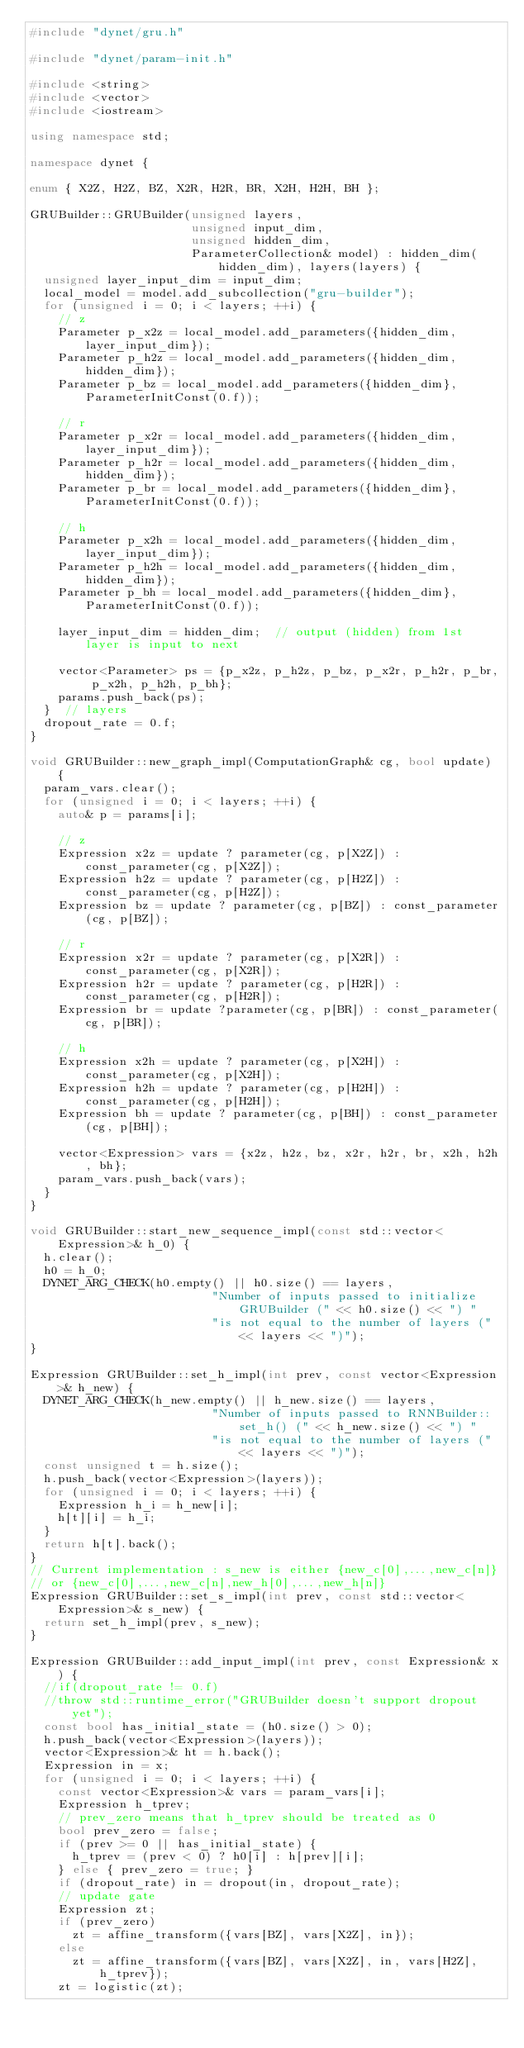<code> <loc_0><loc_0><loc_500><loc_500><_C++_>#include "dynet/gru.h"

#include "dynet/param-init.h"

#include <string>
#include <vector>
#include <iostream>

using namespace std;

namespace dynet {

enum { X2Z, H2Z, BZ, X2R, H2R, BR, X2H, H2H, BH };

GRUBuilder::GRUBuilder(unsigned layers,
                       unsigned input_dim,
                       unsigned hidden_dim,
                       ParameterCollection& model) : hidden_dim(hidden_dim), layers(layers) {
  unsigned layer_input_dim = input_dim;
  local_model = model.add_subcollection("gru-builder");
  for (unsigned i = 0; i < layers; ++i) {
    // z
    Parameter p_x2z = local_model.add_parameters({hidden_dim, layer_input_dim});
    Parameter p_h2z = local_model.add_parameters({hidden_dim, hidden_dim});
    Parameter p_bz = local_model.add_parameters({hidden_dim}, ParameterInitConst(0.f));

    // r
    Parameter p_x2r = local_model.add_parameters({hidden_dim, layer_input_dim});
    Parameter p_h2r = local_model.add_parameters({hidden_dim, hidden_dim});
    Parameter p_br = local_model.add_parameters({hidden_dim}, ParameterInitConst(0.f));

    // h
    Parameter p_x2h = local_model.add_parameters({hidden_dim, layer_input_dim});
    Parameter p_h2h = local_model.add_parameters({hidden_dim, hidden_dim});
    Parameter p_bh = local_model.add_parameters({hidden_dim}, ParameterInitConst(0.f));

    layer_input_dim = hidden_dim;  // output (hidden) from 1st layer is input to next

    vector<Parameter> ps = {p_x2z, p_h2z, p_bz, p_x2r, p_h2r, p_br, p_x2h, p_h2h, p_bh};
    params.push_back(ps);
  }  // layers
  dropout_rate = 0.f;
}

void GRUBuilder::new_graph_impl(ComputationGraph& cg, bool update) {
  param_vars.clear();
  for (unsigned i = 0; i < layers; ++i) {
    auto& p = params[i];

    // z
    Expression x2z = update ? parameter(cg, p[X2Z]) : const_parameter(cg, p[X2Z]);
    Expression h2z = update ? parameter(cg, p[H2Z]) : const_parameter(cg, p[H2Z]);
    Expression bz = update ? parameter(cg, p[BZ]) : const_parameter(cg, p[BZ]);

    // r
    Expression x2r = update ? parameter(cg, p[X2R]) : const_parameter(cg, p[X2R]);
    Expression h2r = update ? parameter(cg, p[H2R]) : const_parameter(cg, p[H2R]);
    Expression br = update ?parameter(cg, p[BR]) : const_parameter(cg, p[BR]);

    // h
    Expression x2h = update ? parameter(cg, p[X2H]) : const_parameter(cg, p[X2H]);
    Expression h2h = update ? parameter(cg, p[H2H]) : const_parameter(cg, p[H2H]);
    Expression bh = update ? parameter(cg, p[BH]) : const_parameter(cg, p[BH]);

    vector<Expression> vars = {x2z, h2z, bz, x2r, h2r, br, x2h, h2h, bh};
    param_vars.push_back(vars);
  }
}

void GRUBuilder::start_new_sequence_impl(const std::vector<Expression>& h_0) {
  h.clear();
  h0 = h_0;
  DYNET_ARG_CHECK(h0.empty() || h0.size() == layers,
                          "Number of inputs passed to initialize GRUBuilder (" << h0.size() << ") "
                          "is not equal to the number of layers (" << layers << ")");
}

Expression GRUBuilder::set_h_impl(int prev, const vector<Expression>& h_new) {
  DYNET_ARG_CHECK(h_new.empty() || h_new.size() == layers,
                          "Number of inputs passed to RNNBuilder::set_h() (" << h_new.size() << ") "
                          "is not equal to the number of layers (" << layers << ")");
  const unsigned t = h.size();
  h.push_back(vector<Expression>(layers));
  for (unsigned i = 0; i < layers; ++i) {
    Expression h_i = h_new[i];
    h[t][i] = h_i;
  }
  return h[t].back();
}
// Current implementation : s_new is either {new_c[0],...,new_c[n]}
// or {new_c[0],...,new_c[n],new_h[0],...,new_h[n]}
Expression GRUBuilder::set_s_impl(int prev, const std::vector<Expression>& s_new) {
  return set_h_impl(prev, s_new);
}

Expression GRUBuilder::add_input_impl(int prev, const Expression& x) {
  //if(dropout_rate != 0.f)
  //throw std::runtime_error("GRUBuilder doesn't support dropout yet");
  const bool has_initial_state = (h0.size() > 0);
  h.push_back(vector<Expression>(layers));
  vector<Expression>& ht = h.back();
  Expression in = x;
  for (unsigned i = 0; i < layers; ++i) {
    const vector<Expression>& vars = param_vars[i];
    Expression h_tprev;
    // prev_zero means that h_tprev should be treated as 0
    bool prev_zero = false;
    if (prev >= 0 || has_initial_state) {
      h_tprev = (prev < 0) ? h0[i] : h[prev][i];
    } else { prev_zero = true; }
    if (dropout_rate) in = dropout(in, dropout_rate);
    // update gate
    Expression zt;
    if (prev_zero)
      zt = affine_transform({vars[BZ], vars[X2Z], in});
    else
      zt = affine_transform({vars[BZ], vars[X2Z], in, vars[H2Z], h_tprev});
    zt = logistic(zt);</code> 